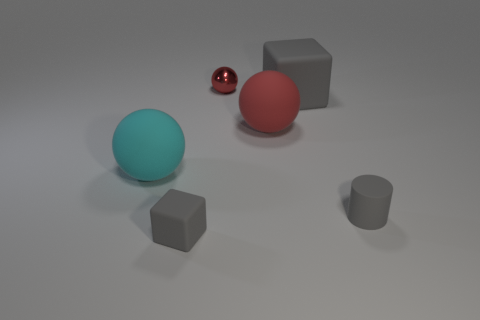There is a small block; is its color the same as the matte cube behind the small matte cylinder?
Your answer should be compact. Yes. Is the number of small metallic things to the right of the tiny gray cylinder less than the number of small objects to the left of the big gray thing?
Your answer should be very brief. Yes. There is a thing that is on the left side of the small gray rubber cylinder and to the right of the big red rubber sphere; what color is it?
Provide a succinct answer. Gray. There is a shiny object; is it the same size as the rubber cube that is on the right side of the tiny gray rubber cube?
Provide a succinct answer. No. There is a small rubber thing that is in front of the gray cylinder; what shape is it?
Your answer should be compact. Cube. Is there any other thing that has the same material as the tiny red object?
Ensure brevity in your answer.  No. Is the number of gray rubber objects to the right of the big gray cube greater than the number of red shiny cylinders?
Ensure brevity in your answer.  Yes. There is a matte cube left of the red object in front of the metallic ball; how many red rubber objects are in front of it?
Provide a succinct answer. 0. There is a rubber thing that is on the right side of the large gray cube; is its size the same as the matte cube that is on the left side of the small red sphere?
Provide a short and direct response. Yes. What is the material of the red sphere that is behind the gray block behind the small gray block?
Provide a short and direct response. Metal. 